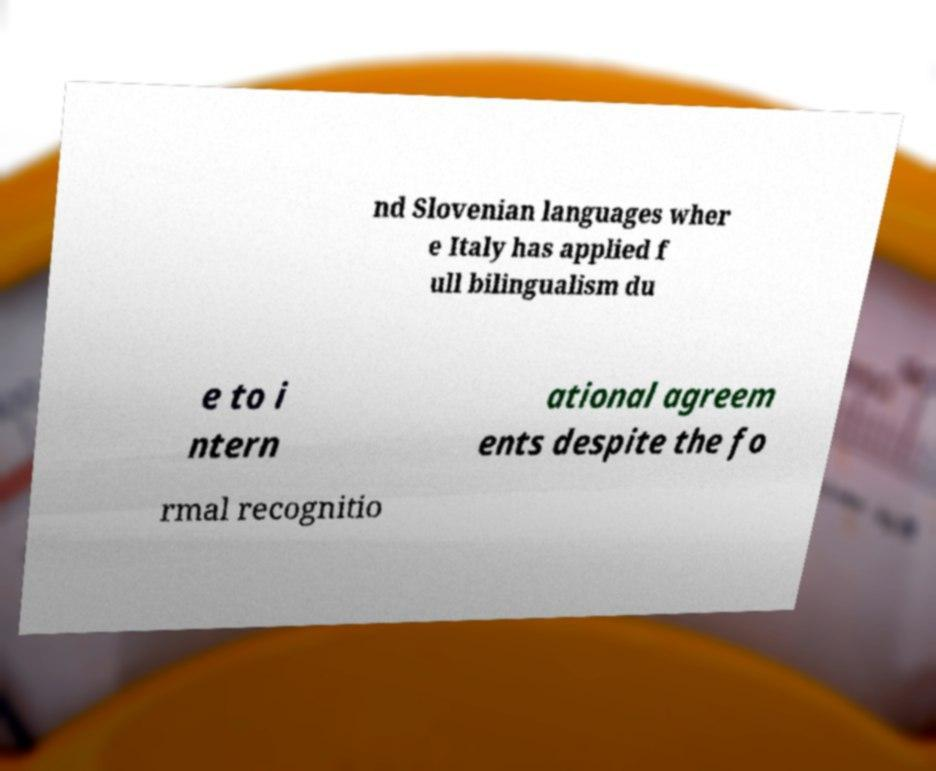I need the written content from this picture converted into text. Can you do that? nd Slovenian languages wher e Italy has applied f ull bilingualism du e to i ntern ational agreem ents despite the fo rmal recognitio 